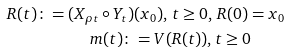Convert formula to latex. <formula><loc_0><loc_0><loc_500><loc_500>R ( t ) \colon = ( X _ { \rho t } \circ Y _ { t } ) & ( x _ { 0 } ) , \, t \geq 0 , \, R ( 0 ) = x _ { 0 } \\ m ( t ) \colon & = V ( R ( t ) ) , t \geq 0</formula> 